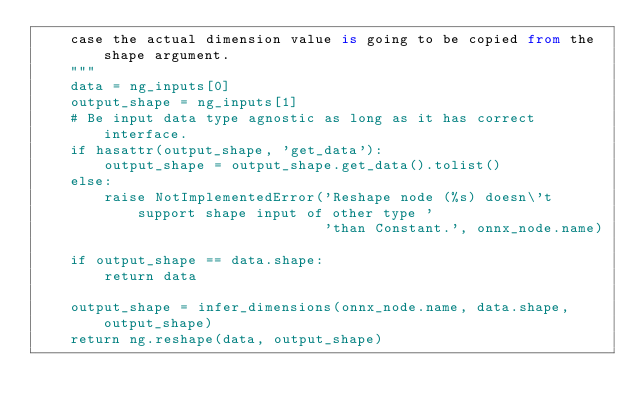<code> <loc_0><loc_0><loc_500><loc_500><_Python_>    case the actual dimension value is going to be copied from the shape argument.
    """
    data = ng_inputs[0]
    output_shape = ng_inputs[1]
    # Be input data type agnostic as long as it has correct interface.
    if hasattr(output_shape, 'get_data'):
        output_shape = output_shape.get_data().tolist()
    else:
        raise NotImplementedError('Reshape node (%s) doesn\'t support shape input of other type '
                                  'than Constant.', onnx_node.name)

    if output_shape == data.shape:
        return data

    output_shape = infer_dimensions(onnx_node.name, data.shape, output_shape)
    return ng.reshape(data, output_shape)
</code> 